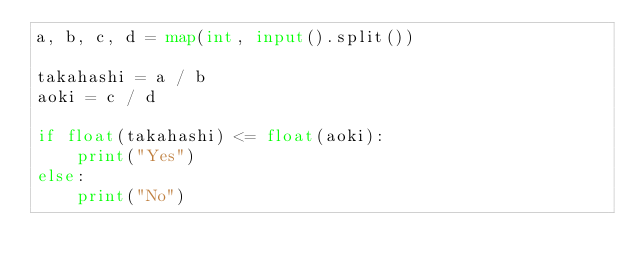Convert code to text. <code><loc_0><loc_0><loc_500><loc_500><_Python_>a, b, c, d = map(int, input().split())

takahashi = a / b
aoki = c / d

if float(takahashi) <= float(aoki):
    print("Yes")
else:
    print("No")</code> 